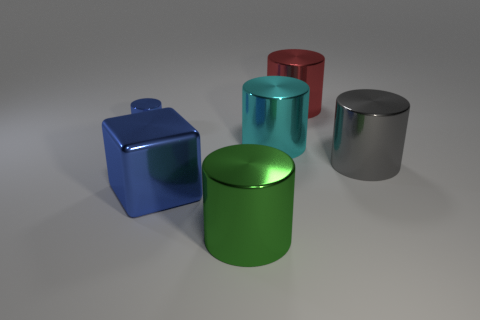Add 1 large green metal cylinders. How many objects exist? 7 Subtract all green cylinders. How many cylinders are left? 4 Subtract all cyan cylinders. How many cylinders are left? 4 Subtract 1 blue cylinders. How many objects are left? 5 Subtract all cylinders. How many objects are left? 1 Subtract 2 cylinders. How many cylinders are left? 3 Subtract all purple cylinders. Subtract all red spheres. How many cylinders are left? 5 Subtract all purple cylinders. How many red cubes are left? 0 Subtract all big gray shiny blocks. Subtract all red shiny cylinders. How many objects are left? 5 Add 4 gray cylinders. How many gray cylinders are left? 5 